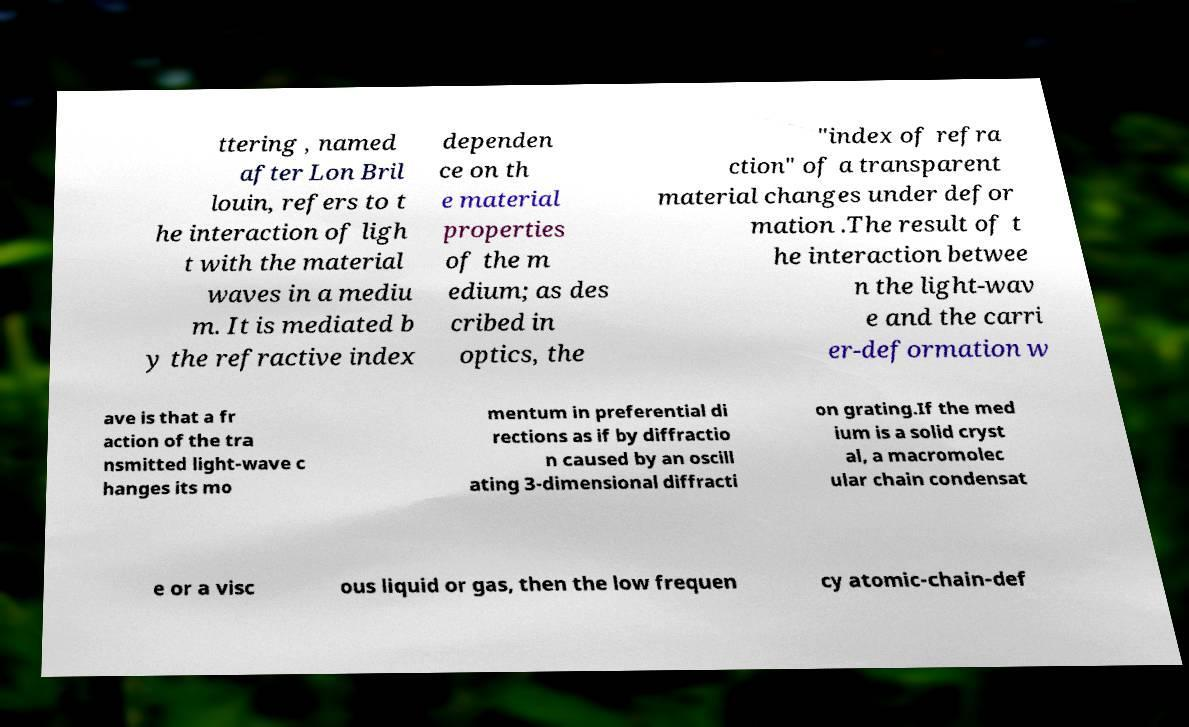I need the written content from this picture converted into text. Can you do that? ttering , named after Lon Bril louin, refers to t he interaction of ligh t with the material waves in a mediu m. It is mediated b y the refractive index dependen ce on th e material properties of the m edium; as des cribed in optics, the "index of refra ction" of a transparent material changes under defor mation .The result of t he interaction betwee n the light-wav e and the carri er-deformation w ave is that a fr action of the tra nsmitted light-wave c hanges its mo mentum in preferential di rections as if by diffractio n caused by an oscill ating 3-dimensional diffracti on grating.If the med ium is a solid cryst al, a macromolec ular chain condensat e or a visc ous liquid or gas, then the low frequen cy atomic-chain-def 